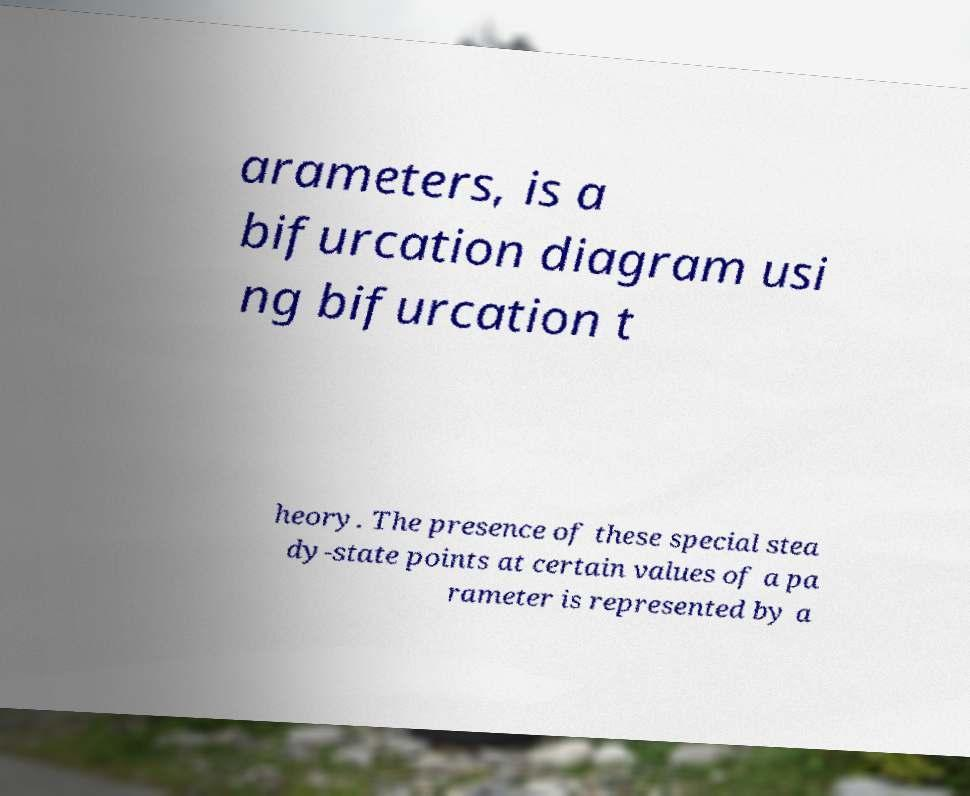Could you assist in decoding the text presented in this image and type it out clearly? arameters, is a bifurcation diagram usi ng bifurcation t heory. The presence of these special stea dy-state points at certain values of a pa rameter is represented by a 